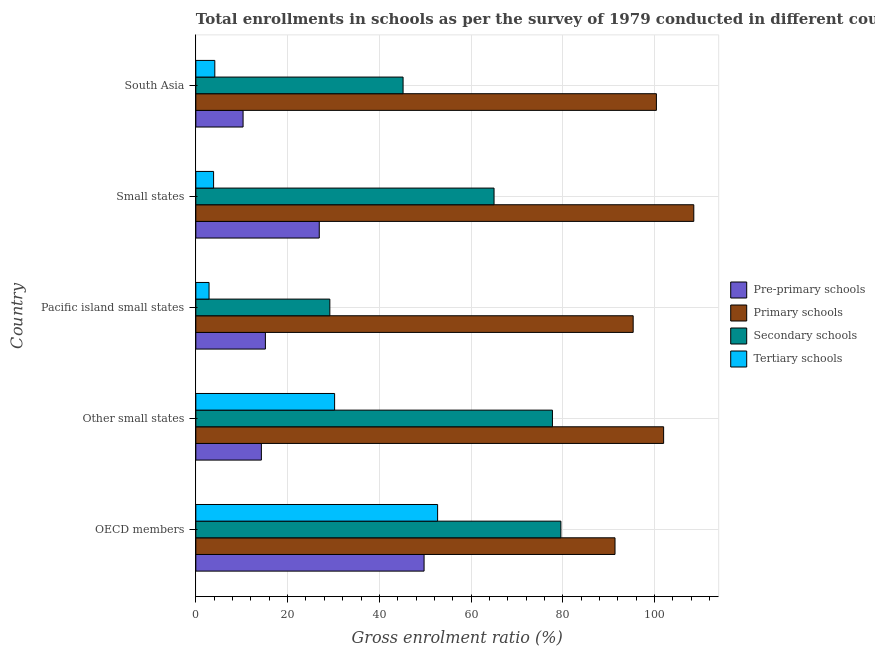Are the number of bars per tick equal to the number of legend labels?
Provide a succinct answer. Yes. Are the number of bars on each tick of the Y-axis equal?
Make the answer very short. Yes. What is the label of the 4th group of bars from the top?
Offer a terse response. Other small states. In how many cases, is the number of bars for a given country not equal to the number of legend labels?
Make the answer very short. 0. What is the gross enrolment ratio in primary schools in Other small states?
Make the answer very short. 101.96. Across all countries, what is the maximum gross enrolment ratio in pre-primary schools?
Provide a short and direct response. 49.75. Across all countries, what is the minimum gross enrolment ratio in pre-primary schools?
Give a very brief answer. 10.3. In which country was the gross enrolment ratio in secondary schools minimum?
Give a very brief answer. Pacific island small states. What is the total gross enrolment ratio in primary schools in the graph?
Your answer should be very brief. 497.57. What is the difference between the gross enrolment ratio in secondary schools in OECD members and that in Other small states?
Ensure brevity in your answer.  1.84. What is the difference between the gross enrolment ratio in tertiary schools in Small states and the gross enrolment ratio in primary schools in OECD members?
Your answer should be compact. -87.49. What is the average gross enrolment ratio in tertiary schools per country?
Offer a terse response. 18.77. What is the difference between the gross enrolment ratio in secondary schools and gross enrolment ratio in tertiary schools in Other small states?
Keep it short and to the point. 47.48. In how many countries, is the gross enrolment ratio in pre-primary schools greater than 36 %?
Make the answer very short. 1. What is the ratio of the gross enrolment ratio in primary schools in OECD members to that in Small states?
Make the answer very short. 0.84. Is the gross enrolment ratio in secondary schools in Other small states less than that in Pacific island small states?
Your answer should be compact. No. What is the difference between the highest and the second highest gross enrolment ratio in secondary schools?
Offer a very short reply. 1.84. What is the difference between the highest and the lowest gross enrolment ratio in primary schools?
Make the answer very short. 17.17. Is it the case that in every country, the sum of the gross enrolment ratio in primary schools and gross enrolment ratio in secondary schools is greater than the sum of gross enrolment ratio in pre-primary schools and gross enrolment ratio in tertiary schools?
Keep it short and to the point. Yes. What does the 1st bar from the top in OECD members represents?
Your answer should be very brief. Tertiary schools. What does the 1st bar from the bottom in Small states represents?
Make the answer very short. Pre-primary schools. Are all the bars in the graph horizontal?
Give a very brief answer. Yes. Are the values on the major ticks of X-axis written in scientific E-notation?
Your answer should be compact. No. Does the graph contain any zero values?
Ensure brevity in your answer.  No. Where does the legend appear in the graph?
Keep it short and to the point. Center right. How many legend labels are there?
Provide a short and direct response. 4. What is the title of the graph?
Your answer should be very brief. Total enrollments in schools as per the survey of 1979 conducted in different countries. Does "Services" appear as one of the legend labels in the graph?
Provide a succinct answer. No. What is the label or title of the X-axis?
Provide a succinct answer. Gross enrolment ratio (%). What is the label or title of the Y-axis?
Provide a short and direct response. Country. What is the Gross enrolment ratio (%) of Pre-primary schools in OECD members?
Offer a very short reply. 49.75. What is the Gross enrolment ratio (%) in Primary schools in OECD members?
Keep it short and to the point. 91.37. What is the Gross enrolment ratio (%) of Secondary schools in OECD members?
Provide a succinct answer. 79.57. What is the Gross enrolment ratio (%) of Tertiary schools in OECD members?
Ensure brevity in your answer.  52.7. What is the Gross enrolment ratio (%) of Pre-primary schools in Other small states?
Your answer should be compact. 14.29. What is the Gross enrolment ratio (%) in Primary schools in Other small states?
Your answer should be very brief. 101.96. What is the Gross enrolment ratio (%) in Secondary schools in Other small states?
Keep it short and to the point. 77.73. What is the Gross enrolment ratio (%) of Tertiary schools in Other small states?
Offer a very short reply. 30.25. What is the Gross enrolment ratio (%) of Pre-primary schools in Pacific island small states?
Your response must be concise. 15.16. What is the Gross enrolment ratio (%) in Primary schools in Pacific island small states?
Your answer should be compact. 95.32. What is the Gross enrolment ratio (%) in Secondary schools in Pacific island small states?
Make the answer very short. 29.21. What is the Gross enrolment ratio (%) of Tertiary schools in Pacific island small states?
Keep it short and to the point. 2.88. What is the Gross enrolment ratio (%) of Pre-primary schools in Small states?
Provide a short and direct response. 26.91. What is the Gross enrolment ratio (%) in Primary schools in Small states?
Give a very brief answer. 108.54. What is the Gross enrolment ratio (%) of Secondary schools in Small states?
Make the answer very short. 65. What is the Gross enrolment ratio (%) in Tertiary schools in Small states?
Provide a short and direct response. 3.87. What is the Gross enrolment ratio (%) of Pre-primary schools in South Asia?
Make the answer very short. 10.3. What is the Gross enrolment ratio (%) of Primary schools in South Asia?
Your answer should be compact. 100.39. What is the Gross enrolment ratio (%) of Secondary schools in South Asia?
Provide a short and direct response. 45.17. What is the Gross enrolment ratio (%) in Tertiary schools in South Asia?
Your answer should be very brief. 4.14. Across all countries, what is the maximum Gross enrolment ratio (%) of Pre-primary schools?
Provide a short and direct response. 49.75. Across all countries, what is the maximum Gross enrolment ratio (%) of Primary schools?
Provide a succinct answer. 108.54. Across all countries, what is the maximum Gross enrolment ratio (%) in Secondary schools?
Make the answer very short. 79.57. Across all countries, what is the maximum Gross enrolment ratio (%) in Tertiary schools?
Ensure brevity in your answer.  52.7. Across all countries, what is the minimum Gross enrolment ratio (%) of Pre-primary schools?
Give a very brief answer. 10.3. Across all countries, what is the minimum Gross enrolment ratio (%) in Primary schools?
Make the answer very short. 91.37. Across all countries, what is the minimum Gross enrolment ratio (%) of Secondary schools?
Offer a terse response. 29.21. Across all countries, what is the minimum Gross enrolment ratio (%) of Tertiary schools?
Offer a very short reply. 2.88. What is the total Gross enrolment ratio (%) of Pre-primary schools in the graph?
Make the answer very short. 116.4. What is the total Gross enrolment ratio (%) of Primary schools in the graph?
Provide a succinct answer. 497.57. What is the total Gross enrolment ratio (%) of Secondary schools in the graph?
Make the answer very short. 296.68. What is the total Gross enrolment ratio (%) of Tertiary schools in the graph?
Provide a succinct answer. 93.84. What is the difference between the Gross enrolment ratio (%) in Pre-primary schools in OECD members and that in Other small states?
Your answer should be compact. 35.46. What is the difference between the Gross enrolment ratio (%) in Primary schools in OECD members and that in Other small states?
Provide a succinct answer. -10.6. What is the difference between the Gross enrolment ratio (%) in Secondary schools in OECD members and that in Other small states?
Provide a succinct answer. 1.84. What is the difference between the Gross enrolment ratio (%) in Tertiary schools in OECD members and that in Other small states?
Offer a terse response. 22.45. What is the difference between the Gross enrolment ratio (%) of Pre-primary schools in OECD members and that in Pacific island small states?
Provide a short and direct response. 34.59. What is the difference between the Gross enrolment ratio (%) in Primary schools in OECD members and that in Pacific island small states?
Provide a short and direct response. -3.96. What is the difference between the Gross enrolment ratio (%) of Secondary schools in OECD members and that in Pacific island small states?
Offer a terse response. 50.36. What is the difference between the Gross enrolment ratio (%) in Tertiary schools in OECD members and that in Pacific island small states?
Give a very brief answer. 49.82. What is the difference between the Gross enrolment ratio (%) in Pre-primary schools in OECD members and that in Small states?
Your response must be concise. 22.84. What is the difference between the Gross enrolment ratio (%) of Primary schools in OECD members and that in Small states?
Ensure brevity in your answer.  -17.17. What is the difference between the Gross enrolment ratio (%) in Secondary schools in OECD members and that in Small states?
Make the answer very short. 14.57. What is the difference between the Gross enrolment ratio (%) in Tertiary schools in OECD members and that in Small states?
Make the answer very short. 48.83. What is the difference between the Gross enrolment ratio (%) of Pre-primary schools in OECD members and that in South Asia?
Keep it short and to the point. 39.45. What is the difference between the Gross enrolment ratio (%) in Primary schools in OECD members and that in South Asia?
Offer a terse response. -9.02. What is the difference between the Gross enrolment ratio (%) in Secondary schools in OECD members and that in South Asia?
Your answer should be very brief. 34.4. What is the difference between the Gross enrolment ratio (%) of Tertiary schools in OECD members and that in South Asia?
Give a very brief answer. 48.56. What is the difference between the Gross enrolment ratio (%) of Pre-primary schools in Other small states and that in Pacific island small states?
Provide a succinct answer. -0.88. What is the difference between the Gross enrolment ratio (%) of Primary schools in Other small states and that in Pacific island small states?
Offer a terse response. 6.64. What is the difference between the Gross enrolment ratio (%) of Secondary schools in Other small states and that in Pacific island small states?
Keep it short and to the point. 48.52. What is the difference between the Gross enrolment ratio (%) in Tertiary schools in Other small states and that in Pacific island small states?
Provide a short and direct response. 27.37. What is the difference between the Gross enrolment ratio (%) in Pre-primary schools in Other small states and that in Small states?
Your answer should be compact. -12.62. What is the difference between the Gross enrolment ratio (%) of Primary schools in Other small states and that in Small states?
Provide a succinct answer. -6.58. What is the difference between the Gross enrolment ratio (%) in Secondary schools in Other small states and that in Small states?
Ensure brevity in your answer.  12.73. What is the difference between the Gross enrolment ratio (%) of Tertiary schools in Other small states and that in Small states?
Ensure brevity in your answer.  26.38. What is the difference between the Gross enrolment ratio (%) in Pre-primary schools in Other small states and that in South Asia?
Your answer should be compact. 3.99. What is the difference between the Gross enrolment ratio (%) in Primary schools in Other small states and that in South Asia?
Your answer should be very brief. 1.57. What is the difference between the Gross enrolment ratio (%) in Secondary schools in Other small states and that in South Asia?
Keep it short and to the point. 32.55. What is the difference between the Gross enrolment ratio (%) of Tertiary schools in Other small states and that in South Asia?
Your answer should be compact. 26.11. What is the difference between the Gross enrolment ratio (%) of Pre-primary schools in Pacific island small states and that in Small states?
Your answer should be compact. -11.75. What is the difference between the Gross enrolment ratio (%) in Primary schools in Pacific island small states and that in Small states?
Offer a very short reply. -13.21. What is the difference between the Gross enrolment ratio (%) of Secondary schools in Pacific island small states and that in Small states?
Provide a succinct answer. -35.79. What is the difference between the Gross enrolment ratio (%) of Tertiary schools in Pacific island small states and that in Small states?
Your answer should be compact. -0.99. What is the difference between the Gross enrolment ratio (%) of Pre-primary schools in Pacific island small states and that in South Asia?
Your response must be concise. 4.86. What is the difference between the Gross enrolment ratio (%) of Primary schools in Pacific island small states and that in South Asia?
Your answer should be very brief. -5.06. What is the difference between the Gross enrolment ratio (%) of Secondary schools in Pacific island small states and that in South Asia?
Ensure brevity in your answer.  -15.96. What is the difference between the Gross enrolment ratio (%) in Tertiary schools in Pacific island small states and that in South Asia?
Your answer should be compact. -1.26. What is the difference between the Gross enrolment ratio (%) of Pre-primary schools in Small states and that in South Asia?
Keep it short and to the point. 16.61. What is the difference between the Gross enrolment ratio (%) in Primary schools in Small states and that in South Asia?
Give a very brief answer. 8.15. What is the difference between the Gross enrolment ratio (%) in Secondary schools in Small states and that in South Asia?
Make the answer very short. 19.83. What is the difference between the Gross enrolment ratio (%) in Tertiary schools in Small states and that in South Asia?
Your answer should be compact. -0.27. What is the difference between the Gross enrolment ratio (%) in Pre-primary schools in OECD members and the Gross enrolment ratio (%) in Primary schools in Other small states?
Offer a very short reply. -52.21. What is the difference between the Gross enrolment ratio (%) of Pre-primary schools in OECD members and the Gross enrolment ratio (%) of Secondary schools in Other small states?
Offer a very short reply. -27.98. What is the difference between the Gross enrolment ratio (%) in Pre-primary schools in OECD members and the Gross enrolment ratio (%) in Tertiary schools in Other small states?
Your response must be concise. 19.5. What is the difference between the Gross enrolment ratio (%) of Primary schools in OECD members and the Gross enrolment ratio (%) of Secondary schools in Other small states?
Provide a succinct answer. 13.64. What is the difference between the Gross enrolment ratio (%) of Primary schools in OECD members and the Gross enrolment ratio (%) of Tertiary schools in Other small states?
Provide a short and direct response. 61.12. What is the difference between the Gross enrolment ratio (%) in Secondary schools in OECD members and the Gross enrolment ratio (%) in Tertiary schools in Other small states?
Keep it short and to the point. 49.32. What is the difference between the Gross enrolment ratio (%) in Pre-primary schools in OECD members and the Gross enrolment ratio (%) in Primary schools in Pacific island small states?
Your answer should be compact. -45.58. What is the difference between the Gross enrolment ratio (%) in Pre-primary schools in OECD members and the Gross enrolment ratio (%) in Secondary schools in Pacific island small states?
Provide a short and direct response. 20.54. What is the difference between the Gross enrolment ratio (%) in Pre-primary schools in OECD members and the Gross enrolment ratio (%) in Tertiary schools in Pacific island small states?
Offer a very short reply. 46.87. What is the difference between the Gross enrolment ratio (%) of Primary schools in OECD members and the Gross enrolment ratio (%) of Secondary schools in Pacific island small states?
Keep it short and to the point. 62.16. What is the difference between the Gross enrolment ratio (%) in Primary schools in OECD members and the Gross enrolment ratio (%) in Tertiary schools in Pacific island small states?
Offer a very short reply. 88.48. What is the difference between the Gross enrolment ratio (%) of Secondary schools in OECD members and the Gross enrolment ratio (%) of Tertiary schools in Pacific island small states?
Make the answer very short. 76.69. What is the difference between the Gross enrolment ratio (%) of Pre-primary schools in OECD members and the Gross enrolment ratio (%) of Primary schools in Small states?
Provide a succinct answer. -58.79. What is the difference between the Gross enrolment ratio (%) in Pre-primary schools in OECD members and the Gross enrolment ratio (%) in Secondary schools in Small states?
Your response must be concise. -15.25. What is the difference between the Gross enrolment ratio (%) in Pre-primary schools in OECD members and the Gross enrolment ratio (%) in Tertiary schools in Small states?
Offer a very short reply. 45.88. What is the difference between the Gross enrolment ratio (%) of Primary schools in OECD members and the Gross enrolment ratio (%) of Secondary schools in Small states?
Make the answer very short. 26.37. What is the difference between the Gross enrolment ratio (%) of Primary schools in OECD members and the Gross enrolment ratio (%) of Tertiary schools in Small states?
Provide a short and direct response. 87.49. What is the difference between the Gross enrolment ratio (%) of Secondary schools in OECD members and the Gross enrolment ratio (%) of Tertiary schools in Small states?
Your answer should be very brief. 75.7. What is the difference between the Gross enrolment ratio (%) in Pre-primary schools in OECD members and the Gross enrolment ratio (%) in Primary schools in South Asia?
Make the answer very short. -50.64. What is the difference between the Gross enrolment ratio (%) of Pre-primary schools in OECD members and the Gross enrolment ratio (%) of Secondary schools in South Asia?
Your answer should be compact. 4.58. What is the difference between the Gross enrolment ratio (%) in Pre-primary schools in OECD members and the Gross enrolment ratio (%) in Tertiary schools in South Asia?
Offer a very short reply. 45.61. What is the difference between the Gross enrolment ratio (%) of Primary schools in OECD members and the Gross enrolment ratio (%) of Secondary schools in South Asia?
Provide a succinct answer. 46.19. What is the difference between the Gross enrolment ratio (%) of Primary schools in OECD members and the Gross enrolment ratio (%) of Tertiary schools in South Asia?
Your answer should be compact. 87.23. What is the difference between the Gross enrolment ratio (%) in Secondary schools in OECD members and the Gross enrolment ratio (%) in Tertiary schools in South Asia?
Provide a succinct answer. 75.43. What is the difference between the Gross enrolment ratio (%) in Pre-primary schools in Other small states and the Gross enrolment ratio (%) in Primary schools in Pacific island small states?
Provide a short and direct response. -81.04. What is the difference between the Gross enrolment ratio (%) of Pre-primary schools in Other small states and the Gross enrolment ratio (%) of Secondary schools in Pacific island small states?
Ensure brevity in your answer.  -14.92. What is the difference between the Gross enrolment ratio (%) of Pre-primary schools in Other small states and the Gross enrolment ratio (%) of Tertiary schools in Pacific island small states?
Make the answer very short. 11.4. What is the difference between the Gross enrolment ratio (%) of Primary schools in Other small states and the Gross enrolment ratio (%) of Secondary schools in Pacific island small states?
Your response must be concise. 72.75. What is the difference between the Gross enrolment ratio (%) of Primary schools in Other small states and the Gross enrolment ratio (%) of Tertiary schools in Pacific island small states?
Ensure brevity in your answer.  99.08. What is the difference between the Gross enrolment ratio (%) of Secondary schools in Other small states and the Gross enrolment ratio (%) of Tertiary schools in Pacific island small states?
Your answer should be very brief. 74.84. What is the difference between the Gross enrolment ratio (%) in Pre-primary schools in Other small states and the Gross enrolment ratio (%) in Primary schools in Small states?
Give a very brief answer. -94.25. What is the difference between the Gross enrolment ratio (%) in Pre-primary schools in Other small states and the Gross enrolment ratio (%) in Secondary schools in Small states?
Keep it short and to the point. -50.71. What is the difference between the Gross enrolment ratio (%) in Pre-primary schools in Other small states and the Gross enrolment ratio (%) in Tertiary schools in Small states?
Offer a very short reply. 10.41. What is the difference between the Gross enrolment ratio (%) of Primary schools in Other small states and the Gross enrolment ratio (%) of Secondary schools in Small states?
Keep it short and to the point. 36.96. What is the difference between the Gross enrolment ratio (%) of Primary schools in Other small states and the Gross enrolment ratio (%) of Tertiary schools in Small states?
Provide a short and direct response. 98.09. What is the difference between the Gross enrolment ratio (%) in Secondary schools in Other small states and the Gross enrolment ratio (%) in Tertiary schools in Small states?
Provide a short and direct response. 73.85. What is the difference between the Gross enrolment ratio (%) in Pre-primary schools in Other small states and the Gross enrolment ratio (%) in Primary schools in South Asia?
Provide a succinct answer. -86.1. What is the difference between the Gross enrolment ratio (%) in Pre-primary schools in Other small states and the Gross enrolment ratio (%) in Secondary schools in South Asia?
Your answer should be compact. -30.89. What is the difference between the Gross enrolment ratio (%) of Pre-primary schools in Other small states and the Gross enrolment ratio (%) of Tertiary schools in South Asia?
Your answer should be very brief. 10.15. What is the difference between the Gross enrolment ratio (%) in Primary schools in Other small states and the Gross enrolment ratio (%) in Secondary schools in South Asia?
Provide a short and direct response. 56.79. What is the difference between the Gross enrolment ratio (%) in Primary schools in Other small states and the Gross enrolment ratio (%) in Tertiary schools in South Asia?
Offer a very short reply. 97.82. What is the difference between the Gross enrolment ratio (%) in Secondary schools in Other small states and the Gross enrolment ratio (%) in Tertiary schools in South Asia?
Offer a very short reply. 73.59. What is the difference between the Gross enrolment ratio (%) in Pre-primary schools in Pacific island small states and the Gross enrolment ratio (%) in Primary schools in Small states?
Provide a succinct answer. -93.38. What is the difference between the Gross enrolment ratio (%) in Pre-primary schools in Pacific island small states and the Gross enrolment ratio (%) in Secondary schools in Small states?
Give a very brief answer. -49.84. What is the difference between the Gross enrolment ratio (%) in Pre-primary schools in Pacific island small states and the Gross enrolment ratio (%) in Tertiary schools in Small states?
Your response must be concise. 11.29. What is the difference between the Gross enrolment ratio (%) in Primary schools in Pacific island small states and the Gross enrolment ratio (%) in Secondary schools in Small states?
Provide a short and direct response. 30.32. What is the difference between the Gross enrolment ratio (%) in Primary schools in Pacific island small states and the Gross enrolment ratio (%) in Tertiary schools in Small states?
Make the answer very short. 91.45. What is the difference between the Gross enrolment ratio (%) in Secondary schools in Pacific island small states and the Gross enrolment ratio (%) in Tertiary schools in Small states?
Offer a very short reply. 25.34. What is the difference between the Gross enrolment ratio (%) in Pre-primary schools in Pacific island small states and the Gross enrolment ratio (%) in Primary schools in South Asia?
Ensure brevity in your answer.  -85.23. What is the difference between the Gross enrolment ratio (%) of Pre-primary schools in Pacific island small states and the Gross enrolment ratio (%) of Secondary schools in South Asia?
Offer a terse response. -30.01. What is the difference between the Gross enrolment ratio (%) in Pre-primary schools in Pacific island small states and the Gross enrolment ratio (%) in Tertiary schools in South Asia?
Offer a very short reply. 11.02. What is the difference between the Gross enrolment ratio (%) in Primary schools in Pacific island small states and the Gross enrolment ratio (%) in Secondary schools in South Asia?
Provide a short and direct response. 50.15. What is the difference between the Gross enrolment ratio (%) of Primary schools in Pacific island small states and the Gross enrolment ratio (%) of Tertiary schools in South Asia?
Give a very brief answer. 91.19. What is the difference between the Gross enrolment ratio (%) in Secondary schools in Pacific island small states and the Gross enrolment ratio (%) in Tertiary schools in South Asia?
Offer a very short reply. 25.07. What is the difference between the Gross enrolment ratio (%) in Pre-primary schools in Small states and the Gross enrolment ratio (%) in Primary schools in South Asia?
Keep it short and to the point. -73.48. What is the difference between the Gross enrolment ratio (%) in Pre-primary schools in Small states and the Gross enrolment ratio (%) in Secondary schools in South Asia?
Give a very brief answer. -18.27. What is the difference between the Gross enrolment ratio (%) in Pre-primary schools in Small states and the Gross enrolment ratio (%) in Tertiary schools in South Asia?
Your answer should be compact. 22.77. What is the difference between the Gross enrolment ratio (%) in Primary schools in Small states and the Gross enrolment ratio (%) in Secondary schools in South Asia?
Provide a short and direct response. 63.36. What is the difference between the Gross enrolment ratio (%) in Primary schools in Small states and the Gross enrolment ratio (%) in Tertiary schools in South Asia?
Give a very brief answer. 104.4. What is the difference between the Gross enrolment ratio (%) of Secondary schools in Small states and the Gross enrolment ratio (%) of Tertiary schools in South Asia?
Offer a terse response. 60.86. What is the average Gross enrolment ratio (%) in Pre-primary schools per country?
Provide a succinct answer. 23.28. What is the average Gross enrolment ratio (%) in Primary schools per country?
Your response must be concise. 99.51. What is the average Gross enrolment ratio (%) of Secondary schools per country?
Ensure brevity in your answer.  59.34. What is the average Gross enrolment ratio (%) of Tertiary schools per country?
Ensure brevity in your answer.  18.77. What is the difference between the Gross enrolment ratio (%) of Pre-primary schools and Gross enrolment ratio (%) of Primary schools in OECD members?
Ensure brevity in your answer.  -41.62. What is the difference between the Gross enrolment ratio (%) of Pre-primary schools and Gross enrolment ratio (%) of Secondary schools in OECD members?
Make the answer very short. -29.82. What is the difference between the Gross enrolment ratio (%) of Pre-primary schools and Gross enrolment ratio (%) of Tertiary schools in OECD members?
Offer a terse response. -2.95. What is the difference between the Gross enrolment ratio (%) in Primary schools and Gross enrolment ratio (%) in Secondary schools in OECD members?
Your answer should be very brief. 11.8. What is the difference between the Gross enrolment ratio (%) in Primary schools and Gross enrolment ratio (%) in Tertiary schools in OECD members?
Offer a terse response. 38.67. What is the difference between the Gross enrolment ratio (%) of Secondary schools and Gross enrolment ratio (%) of Tertiary schools in OECD members?
Provide a short and direct response. 26.87. What is the difference between the Gross enrolment ratio (%) of Pre-primary schools and Gross enrolment ratio (%) of Primary schools in Other small states?
Your answer should be compact. -87.68. What is the difference between the Gross enrolment ratio (%) in Pre-primary schools and Gross enrolment ratio (%) in Secondary schools in Other small states?
Give a very brief answer. -63.44. What is the difference between the Gross enrolment ratio (%) in Pre-primary schools and Gross enrolment ratio (%) in Tertiary schools in Other small states?
Offer a terse response. -15.96. What is the difference between the Gross enrolment ratio (%) of Primary schools and Gross enrolment ratio (%) of Secondary schools in Other small states?
Offer a very short reply. 24.24. What is the difference between the Gross enrolment ratio (%) of Primary schools and Gross enrolment ratio (%) of Tertiary schools in Other small states?
Your answer should be compact. 71.71. What is the difference between the Gross enrolment ratio (%) of Secondary schools and Gross enrolment ratio (%) of Tertiary schools in Other small states?
Offer a terse response. 47.48. What is the difference between the Gross enrolment ratio (%) in Pre-primary schools and Gross enrolment ratio (%) in Primary schools in Pacific island small states?
Provide a short and direct response. -80.16. What is the difference between the Gross enrolment ratio (%) of Pre-primary schools and Gross enrolment ratio (%) of Secondary schools in Pacific island small states?
Ensure brevity in your answer.  -14.05. What is the difference between the Gross enrolment ratio (%) of Pre-primary schools and Gross enrolment ratio (%) of Tertiary schools in Pacific island small states?
Your answer should be very brief. 12.28. What is the difference between the Gross enrolment ratio (%) of Primary schools and Gross enrolment ratio (%) of Secondary schools in Pacific island small states?
Offer a very short reply. 66.12. What is the difference between the Gross enrolment ratio (%) of Primary schools and Gross enrolment ratio (%) of Tertiary schools in Pacific island small states?
Make the answer very short. 92.44. What is the difference between the Gross enrolment ratio (%) of Secondary schools and Gross enrolment ratio (%) of Tertiary schools in Pacific island small states?
Ensure brevity in your answer.  26.33. What is the difference between the Gross enrolment ratio (%) of Pre-primary schools and Gross enrolment ratio (%) of Primary schools in Small states?
Keep it short and to the point. -81.63. What is the difference between the Gross enrolment ratio (%) of Pre-primary schools and Gross enrolment ratio (%) of Secondary schools in Small states?
Keep it short and to the point. -38.09. What is the difference between the Gross enrolment ratio (%) in Pre-primary schools and Gross enrolment ratio (%) in Tertiary schools in Small states?
Give a very brief answer. 23.03. What is the difference between the Gross enrolment ratio (%) of Primary schools and Gross enrolment ratio (%) of Secondary schools in Small states?
Your answer should be very brief. 43.54. What is the difference between the Gross enrolment ratio (%) of Primary schools and Gross enrolment ratio (%) of Tertiary schools in Small states?
Your answer should be compact. 104.67. What is the difference between the Gross enrolment ratio (%) of Secondary schools and Gross enrolment ratio (%) of Tertiary schools in Small states?
Make the answer very short. 61.13. What is the difference between the Gross enrolment ratio (%) in Pre-primary schools and Gross enrolment ratio (%) in Primary schools in South Asia?
Your answer should be compact. -90.09. What is the difference between the Gross enrolment ratio (%) in Pre-primary schools and Gross enrolment ratio (%) in Secondary schools in South Asia?
Your response must be concise. -34.87. What is the difference between the Gross enrolment ratio (%) of Pre-primary schools and Gross enrolment ratio (%) of Tertiary schools in South Asia?
Offer a very short reply. 6.16. What is the difference between the Gross enrolment ratio (%) of Primary schools and Gross enrolment ratio (%) of Secondary schools in South Asia?
Provide a succinct answer. 55.21. What is the difference between the Gross enrolment ratio (%) in Primary schools and Gross enrolment ratio (%) in Tertiary schools in South Asia?
Keep it short and to the point. 96.25. What is the difference between the Gross enrolment ratio (%) of Secondary schools and Gross enrolment ratio (%) of Tertiary schools in South Asia?
Offer a terse response. 41.04. What is the ratio of the Gross enrolment ratio (%) in Pre-primary schools in OECD members to that in Other small states?
Ensure brevity in your answer.  3.48. What is the ratio of the Gross enrolment ratio (%) in Primary schools in OECD members to that in Other small states?
Your response must be concise. 0.9. What is the ratio of the Gross enrolment ratio (%) of Secondary schools in OECD members to that in Other small states?
Your response must be concise. 1.02. What is the ratio of the Gross enrolment ratio (%) in Tertiary schools in OECD members to that in Other small states?
Provide a short and direct response. 1.74. What is the ratio of the Gross enrolment ratio (%) of Pre-primary schools in OECD members to that in Pacific island small states?
Offer a very short reply. 3.28. What is the ratio of the Gross enrolment ratio (%) of Primary schools in OECD members to that in Pacific island small states?
Make the answer very short. 0.96. What is the ratio of the Gross enrolment ratio (%) in Secondary schools in OECD members to that in Pacific island small states?
Provide a short and direct response. 2.72. What is the ratio of the Gross enrolment ratio (%) in Tertiary schools in OECD members to that in Pacific island small states?
Make the answer very short. 18.29. What is the ratio of the Gross enrolment ratio (%) in Pre-primary schools in OECD members to that in Small states?
Offer a terse response. 1.85. What is the ratio of the Gross enrolment ratio (%) of Primary schools in OECD members to that in Small states?
Provide a short and direct response. 0.84. What is the ratio of the Gross enrolment ratio (%) of Secondary schools in OECD members to that in Small states?
Make the answer very short. 1.22. What is the ratio of the Gross enrolment ratio (%) of Tertiary schools in OECD members to that in Small states?
Provide a succinct answer. 13.61. What is the ratio of the Gross enrolment ratio (%) in Pre-primary schools in OECD members to that in South Asia?
Your response must be concise. 4.83. What is the ratio of the Gross enrolment ratio (%) in Primary schools in OECD members to that in South Asia?
Offer a very short reply. 0.91. What is the ratio of the Gross enrolment ratio (%) of Secondary schools in OECD members to that in South Asia?
Keep it short and to the point. 1.76. What is the ratio of the Gross enrolment ratio (%) of Tertiary schools in OECD members to that in South Asia?
Offer a terse response. 12.74. What is the ratio of the Gross enrolment ratio (%) of Pre-primary schools in Other small states to that in Pacific island small states?
Your answer should be compact. 0.94. What is the ratio of the Gross enrolment ratio (%) of Primary schools in Other small states to that in Pacific island small states?
Your response must be concise. 1.07. What is the ratio of the Gross enrolment ratio (%) in Secondary schools in Other small states to that in Pacific island small states?
Give a very brief answer. 2.66. What is the ratio of the Gross enrolment ratio (%) of Tertiary schools in Other small states to that in Pacific island small states?
Your answer should be compact. 10.5. What is the ratio of the Gross enrolment ratio (%) of Pre-primary schools in Other small states to that in Small states?
Provide a succinct answer. 0.53. What is the ratio of the Gross enrolment ratio (%) in Primary schools in Other small states to that in Small states?
Provide a short and direct response. 0.94. What is the ratio of the Gross enrolment ratio (%) of Secondary schools in Other small states to that in Small states?
Provide a short and direct response. 1.2. What is the ratio of the Gross enrolment ratio (%) of Tertiary schools in Other small states to that in Small states?
Keep it short and to the point. 7.81. What is the ratio of the Gross enrolment ratio (%) in Pre-primary schools in Other small states to that in South Asia?
Your answer should be compact. 1.39. What is the ratio of the Gross enrolment ratio (%) of Primary schools in Other small states to that in South Asia?
Make the answer very short. 1.02. What is the ratio of the Gross enrolment ratio (%) in Secondary schools in Other small states to that in South Asia?
Make the answer very short. 1.72. What is the ratio of the Gross enrolment ratio (%) in Tertiary schools in Other small states to that in South Asia?
Make the answer very short. 7.31. What is the ratio of the Gross enrolment ratio (%) of Pre-primary schools in Pacific island small states to that in Small states?
Make the answer very short. 0.56. What is the ratio of the Gross enrolment ratio (%) of Primary schools in Pacific island small states to that in Small states?
Ensure brevity in your answer.  0.88. What is the ratio of the Gross enrolment ratio (%) in Secondary schools in Pacific island small states to that in Small states?
Offer a very short reply. 0.45. What is the ratio of the Gross enrolment ratio (%) in Tertiary schools in Pacific island small states to that in Small states?
Your response must be concise. 0.74. What is the ratio of the Gross enrolment ratio (%) in Pre-primary schools in Pacific island small states to that in South Asia?
Keep it short and to the point. 1.47. What is the ratio of the Gross enrolment ratio (%) in Primary schools in Pacific island small states to that in South Asia?
Make the answer very short. 0.95. What is the ratio of the Gross enrolment ratio (%) in Secondary schools in Pacific island small states to that in South Asia?
Provide a short and direct response. 0.65. What is the ratio of the Gross enrolment ratio (%) of Tertiary schools in Pacific island small states to that in South Asia?
Your answer should be very brief. 0.7. What is the ratio of the Gross enrolment ratio (%) of Pre-primary schools in Small states to that in South Asia?
Give a very brief answer. 2.61. What is the ratio of the Gross enrolment ratio (%) of Primary schools in Small states to that in South Asia?
Your answer should be very brief. 1.08. What is the ratio of the Gross enrolment ratio (%) of Secondary schools in Small states to that in South Asia?
Offer a very short reply. 1.44. What is the ratio of the Gross enrolment ratio (%) of Tertiary schools in Small states to that in South Asia?
Offer a very short reply. 0.94. What is the difference between the highest and the second highest Gross enrolment ratio (%) of Pre-primary schools?
Provide a succinct answer. 22.84. What is the difference between the highest and the second highest Gross enrolment ratio (%) of Primary schools?
Provide a succinct answer. 6.58. What is the difference between the highest and the second highest Gross enrolment ratio (%) in Secondary schools?
Your answer should be very brief. 1.84. What is the difference between the highest and the second highest Gross enrolment ratio (%) in Tertiary schools?
Your answer should be very brief. 22.45. What is the difference between the highest and the lowest Gross enrolment ratio (%) in Pre-primary schools?
Offer a terse response. 39.45. What is the difference between the highest and the lowest Gross enrolment ratio (%) in Primary schools?
Ensure brevity in your answer.  17.17. What is the difference between the highest and the lowest Gross enrolment ratio (%) in Secondary schools?
Ensure brevity in your answer.  50.36. What is the difference between the highest and the lowest Gross enrolment ratio (%) in Tertiary schools?
Provide a succinct answer. 49.82. 